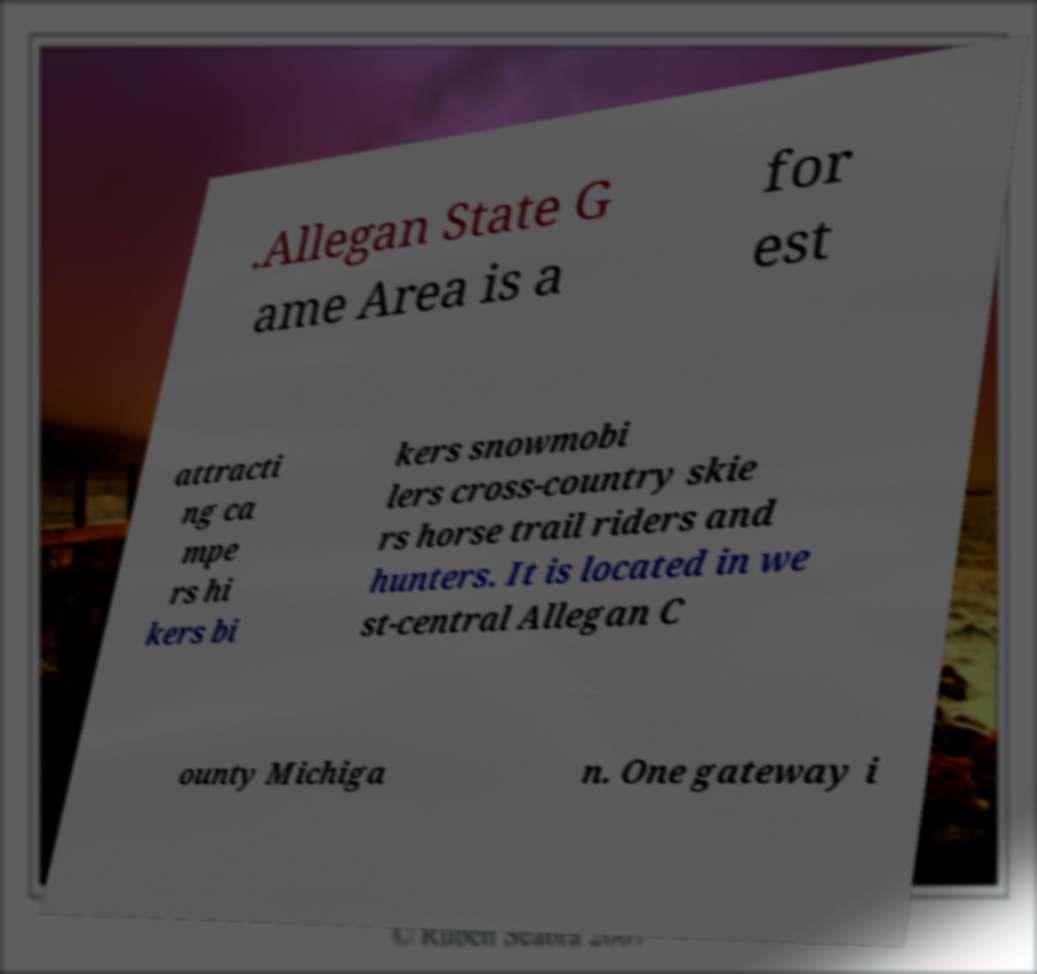For documentation purposes, I need the text within this image transcribed. Could you provide that? .Allegan State G ame Area is a for est attracti ng ca mpe rs hi kers bi kers snowmobi lers cross-country skie rs horse trail riders and hunters. It is located in we st-central Allegan C ounty Michiga n. One gateway i 